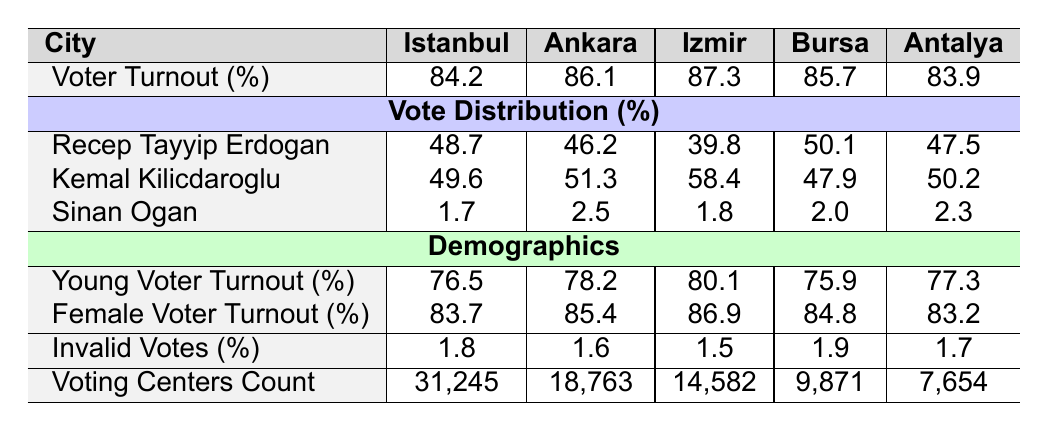What was the voter turnout percentage in Istanbul? The table lists the voter turnout for Istanbul as 84.2% under the "Voter Turnout (%)" row.
Answer: 84.2% Which candidate received the highest percentage of votes in Izmir? In the "Vote Distribution (%)" section, Kemal Kilicdaroglu received the highest percentage of votes in Izmir at 58.4%.
Answer: Kemal Kilicdaroglu What percentage of invalid votes were recorded in Ankara? According to the "Invalid Votes (%)" row, the percentage of invalid votes in Ankara is 1.6%.
Answer: 1.6% Is the voter turnout for young voters in Antalya higher or lower than the average for all cities? The young voter turnout in Antalya is 77.3%. The average young voter turnout for all cities can be calculated as (76.5 + 78.2 + 80.1 + 75.9 + 77.3) / 5 = 77.4%. Since 77.3% is lower than the average, the answer is lower.
Answer: Lower What is the difference in voting centers count between Istanbul and Antalya? The voting centers count for Istanbul is 31,245 and for Antalya is 7,654. The difference is 31,245 - 7,654 = 23,591.
Answer: 23,591 Which city had the lowest percentage of votes for Recep Tayyip Erdogan? Examining the "Vote Distribution (%)" for Erdogan, the lowest percentage is in Izmir, where he received 39.8%.
Answer: Izmir How does female voter turnout compare between Bursa and Ankara? Female voter turnout for Bursa is 84.8%, while for Ankara it is 85.4%. Comparing these, Ankara has a higher female voter turnout by 85.4% - 84.8% = 0.6%.
Answer: Higher in Ankara What was the average voter turnout across all cities listed? The average can be calculated by summing the voter turnout percentages: (84.2 + 86.1 + 87.3 + 85.7 + 83.9) / 5 = 85.44%.
Answer: 85.44% Did Sinan Ogan receive more votes than the invalid votes percentage in Izmir? Sinan Ogan received 1.8% of the votes while invalid votes in Izmir were 1.5%. Since 1.8% is greater than 1.5%, the answer is yes.
Answer: Yes Which candidate had the lowest voting percentage across all cities? By checking the "Vote Distribution (%)" section, Sinan Ogan had the lowest percentage of votes, with the highest being 2.5% (in Ankara).
Answer: Sinan Ogan 